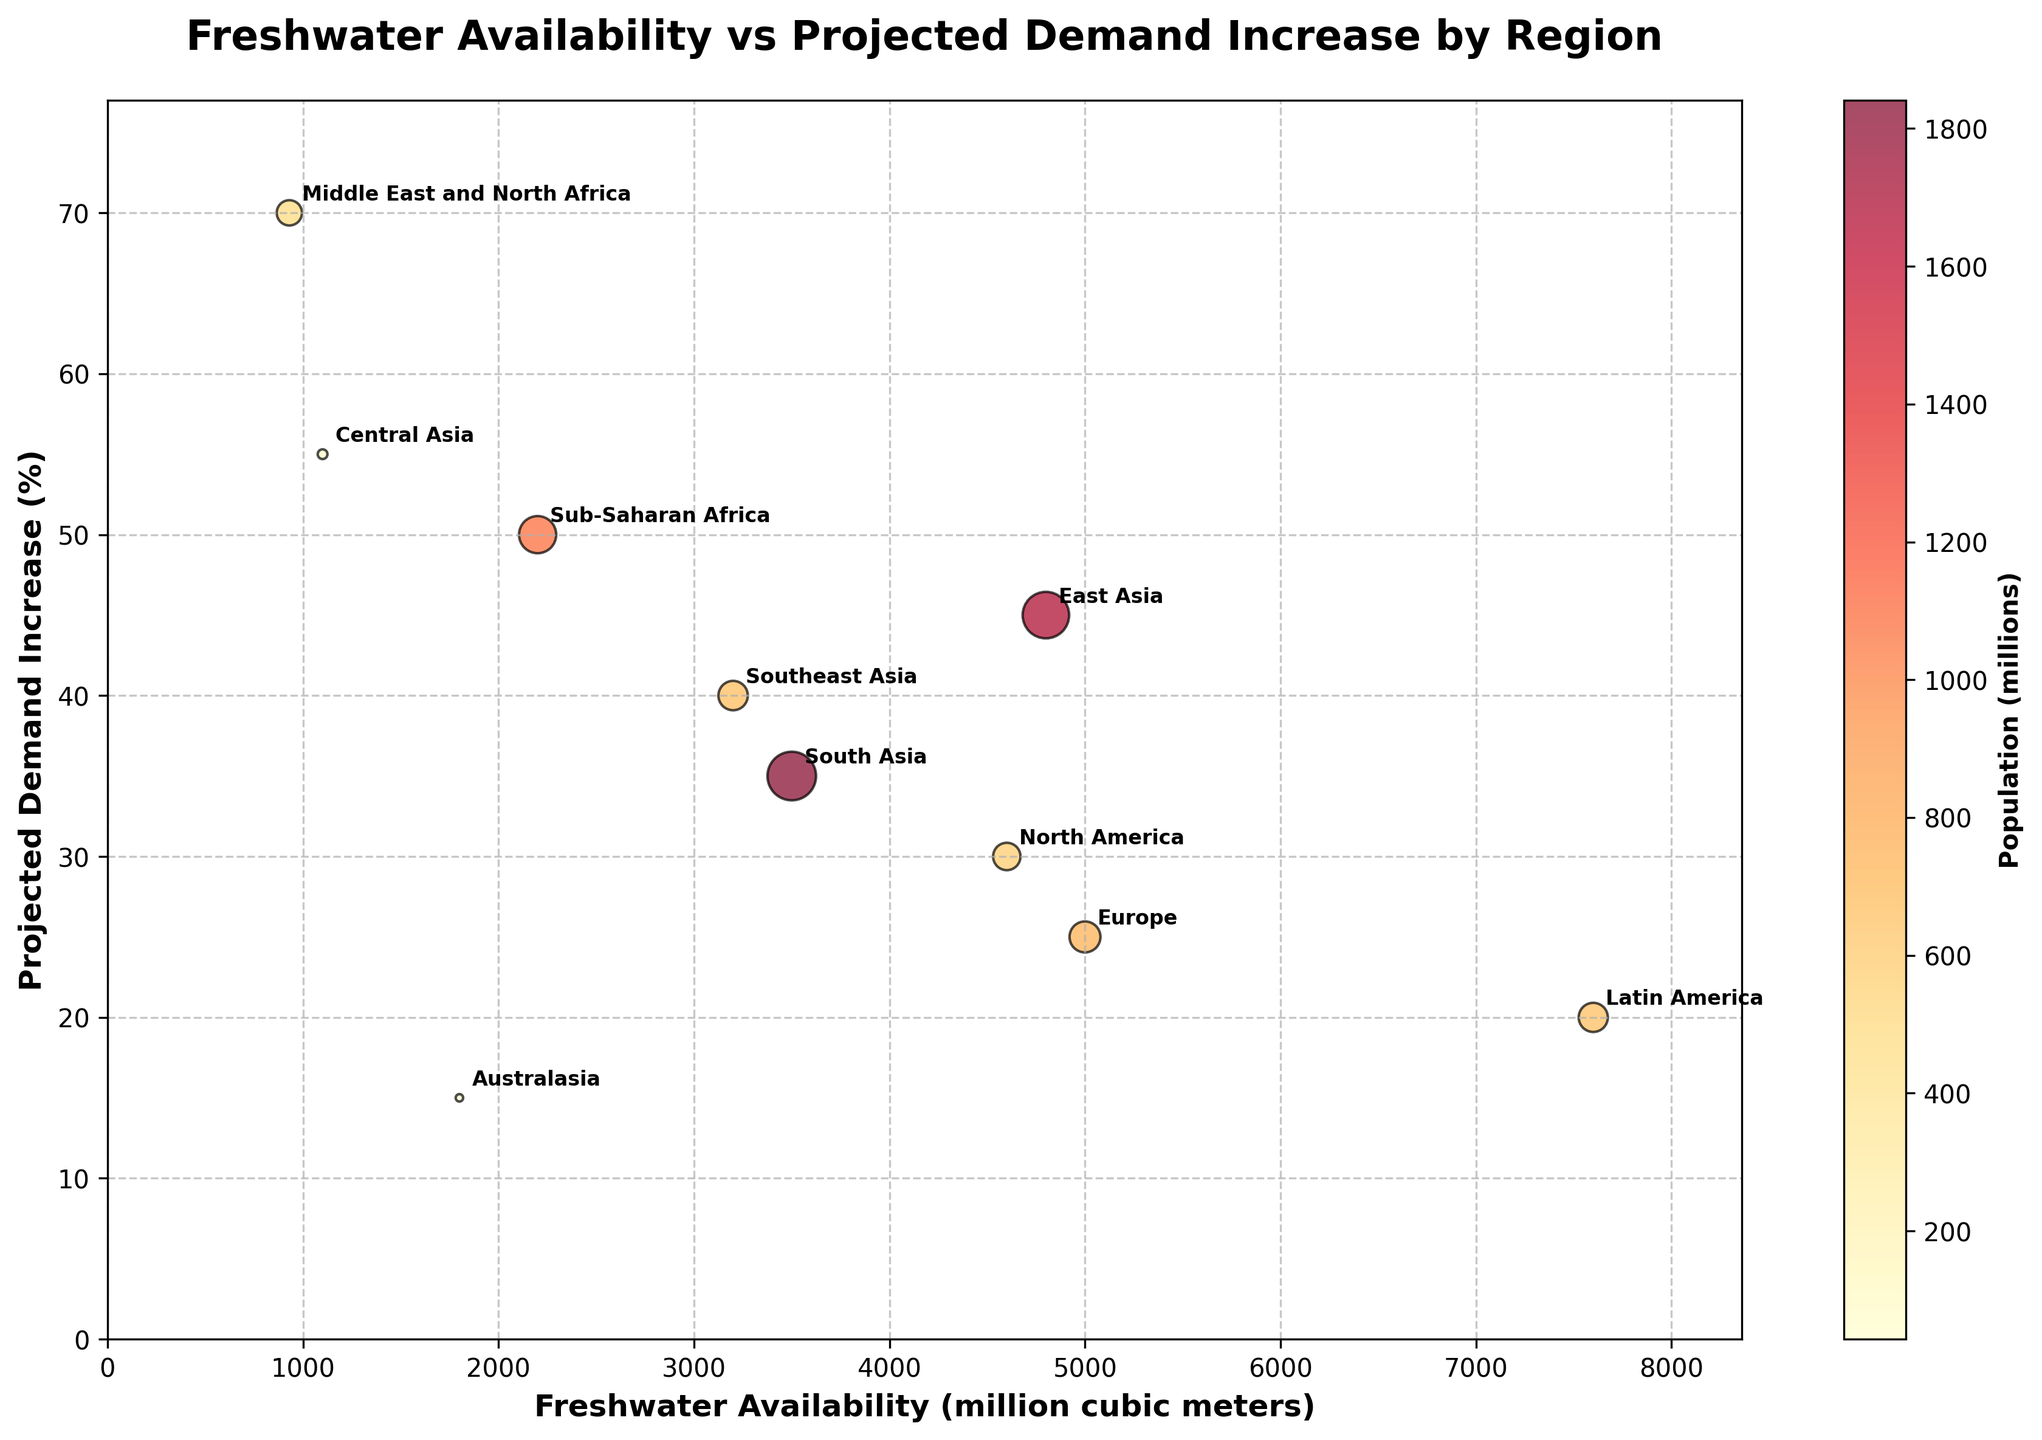What is the title of the figure? The title of the figure can be found at the top center of the plot. It usually describes the main content and purpose of the visual representation. In this case, the title is "Freshwater Availability vs Projected Demand Increase by Region".
Answer: Freshwater Availability vs Projected Demand Increase by Region How many regions are represented in the plot? To determine the number of regions represented, count the distinct labels (annotations) attached to the bubbles in the plot. Each bubble is labeled with a region's name. By counting these labels, we can see there are 10 regions.
Answer: 10 Which region has the highest projected demand increase in percentage? To find the region with the highest demand increase, look at the y-axis (Projected Demand Increase (%)) and identify the bubble positioned highest along this axis. The region Middle East and North Africa is at the 70% mark, the highest on the y-axis.
Answer: Middle East and North Africa What is the projected demand increase percentage for Latin America? Locate the bubble for Latin America and read its position on the y-axis (Projected Demand Increase (%)). The bubble for Latin America is at the 20% mark.
Answer: 20% What is the difference in projected demand increase between Sub-Saharan Africa and Central Asia? To find the difference, subtract the projected demand increase percentage of one region from the other. Sub-Saharan Africa has a projected demand increase of 50%, and Central Asia has 55%. Therefore, the difference is 55% - 50% = 5%.
Answer: 5% Which region has the largest population, and how do you know? To identify the region with the largest population, look at the bubble size. Larger bubbles correspond to larger populations. East Asia has the largest bubble, indicating it has the largest population of 1686 million.
Answer: East Asia Compare the availability of freshwater resources between North America and Europe. Which region has more resources? Find the bubbles for North America and Europe, then check their positions on the x-axis (Freshwater Availability (million cubic meters)). North America has about 4600 million cubic meters, while Europe has 5000 million cubic meters, indicating Europe has more freshwater resources.
Answer: Europe Which regions have both a projected demand increase of over 40% and relatively larger population sizes? Identify bubbles above the 40% mark on the y-axis and check their size (population). Sub-Saharan Africa, Southeast Asia, and East Asia all meet these criteria, with large bubbles (populations) and projected demand increases of 50%, 40%, and 45%, respectively.
Answer: Sub-Saharan Africa, Southeast Asia, and East Asia What is the combined availability of freshwater resources for Sub-Saharan Africa and South Asia? Sum the freshwater availability for these two regions. Sub-Saharan Africa has 2200 million cubic meters, and South Asia has 3500 million cubic meters. Therefore, the combined availability is 2200 + 3500 = 5700 million cubic meters.
Answer: 5700 million cubic meters 